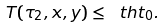<formula> <loc_0><loc_0><loc_500><loc_500>T ( \tau _ { 2 } , x , y ) \leq \ t h t _ { 0 } .</formula> 